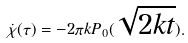Convert formula to latex. <formula><loc_0><loc_0><loc_500><loc_500>\dot { \chi } ( \tau ) = - 2 \pi k P _ { 0 } ( \sqrt { 2 k t } ) .</formula> 